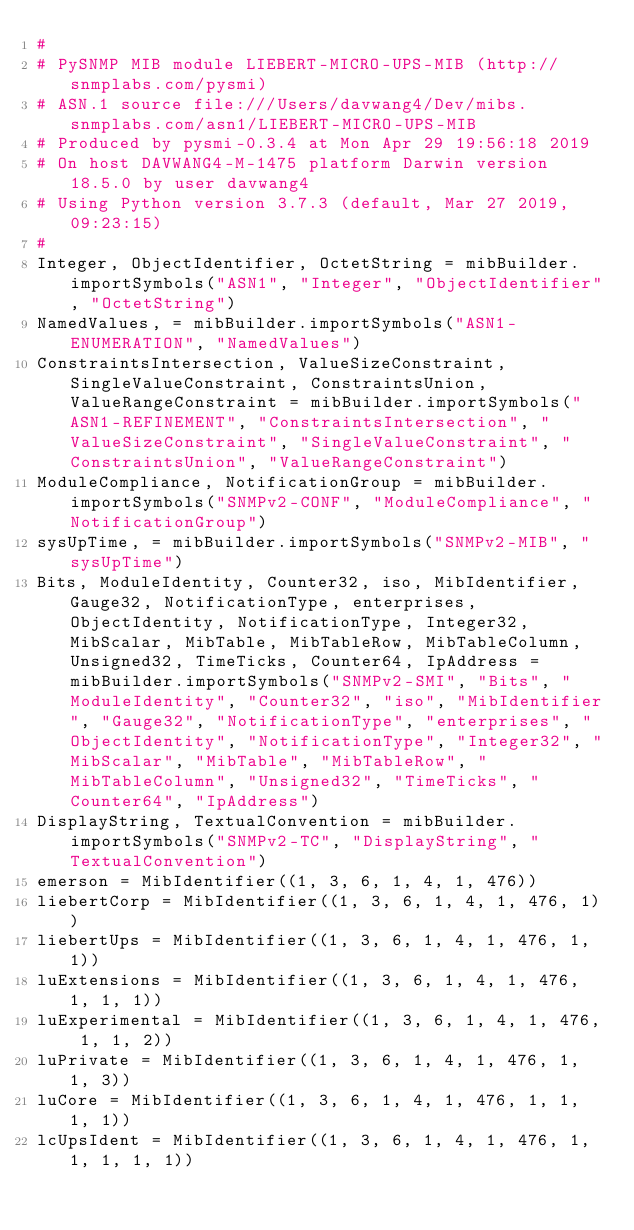<code> <loc_0><loc_0><loc_500><loc_500><_Python_>#
# PySNMP MIB module LIEBERT-MICRO-UPS-MIB (http://snmplabs.com/pysmi)
# ASN.1 source file:///Users/davwang4/Dev/mibs.snmplabs.com/asn1/LIEBERT-MICRO-UPS-MIB
# Produced by pysmi-0.3.4 at Mon Apr 29 19:56:18 2019
# On host DAVWANG4-M-1475 platform Darwin version 18.5.0 by user davwang4
# Using Python version 3.7.3 (default, Mar 27 2019, 09:23:15) 
#
Integer, ObjectIdentifier, OctetString = mibBuilder.importSymbols("ASN1", "Integer", "ObjectIdentifier", "OctetString")
NamedValues, = mibBuilder.importSymbols("ASN1-ENUMERATION", "NamedValues")
ConstraintsIntersection, ValueSizeConstraint, SingleValueConstraint, ConstraintsUnion, ValueRangeConstraint = mibBuilder.importSymbols("ASN1-REFINEMENT", "ConstraintsIntersection", "ValueSizeConstraint", "SingleValueConstraint", "ConstraintsUnion", "ValueRangeConstraint")
ModuleCompliance, NotificationGroup = mibBuilder.importSymbols("SNMPv2-CONF", "ModuleCompliance", "NotificationGroup")
sysUpTime, = mibBuilder.importSymbols("SNMPv2-MIB", "sysUpTime")
Bits, ModuleIdentity, Counter32, iso, MibIdentifier, Gauge32, NotificationType, enterprises, ObjectIdentity, NotificationType, Integer32, MibScalar, MibTable, MibTableRow, MibTableColumn, Unsigned32, TimeTicks, Counter64, IpAddress = mibBuilder.importSymbols("SNMPv2-SMI", "Bits", "ModuleIdentity", "Counter32", "iso", "MibIdentifier", "Gauge32", "NotificationType", "enterprises", "ObjectIdentity", "NotificationType", "Integer32", "MibScalar", "MibTable", "MibTableRow", "MibTableColumn", "Unsigned32", "TimeTicks", "Counter64", "IpAddress")
DisplayString, TextualConvention = mibBuilder.importSymbols("SNMPv2-TC", "DisplayString", "TextualConvention")
emerson = MibIdentifier((1, 3, 6, 1, 4, 1, 476))
liebertCorp = MibIdentifier((1, 3, 6, 1, 4, 1, 476, 1))
liebertUps = MibIdentifier((1, 3, 6, 1, 4, 1, 476, 1, 1))
luExtensions = MibIdentifier((1, 3, 6, 1, 4, 1, 476, 1, 1, 1))
luExperimental = MibIdentifier((1, 3, 6, 1, 4, 1, 476, 1, 1, 2))
luPrivate = MibIdentifier((1, 3, 6, 1, 4, 1, 476, 1, 1, 3))
luCore = MibIdentifier((1, 3, 6, 1, 4, 1, 476, 1, 1, 1, 1))
lcUpsIdent = MibIdentifier((1, 3, 6, 1, 4, 1, 476, 1, 1, 1, 1, 1))</code> 